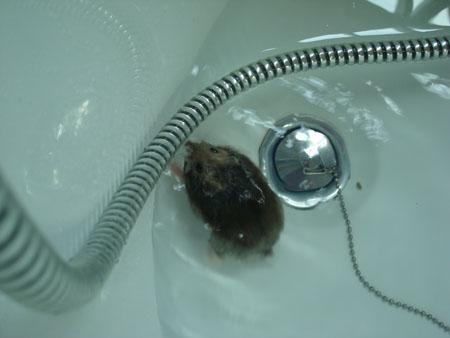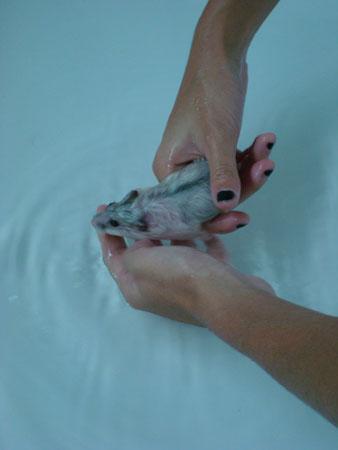The first image is the image on the left, the second image is the image on the right. Assess this claim about the two images: "in the right side image, there is a human hand holding the animal". Correct or not? Answer yes or no. Yes. 